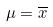<formula> <loc_0><loc_0><loc_500><loc_500>\mu = \overline { x }</formula> 